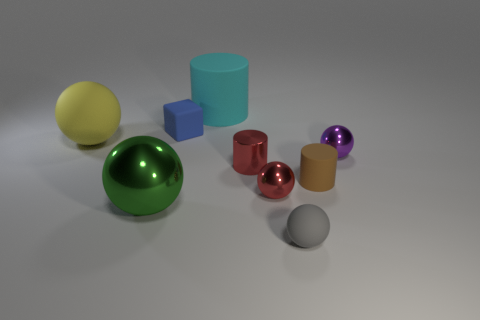What number of other objects are the same material as the red cylinder?
Your answer should be very brief. 3. Is the material of the large object right of the tiny rubber block the same as the tiny blue cube?
Offer a terse response. Yes. What size is the sphere that is behind the metal sphere that is behind the red thing that is to the right of the tiny red cylinder?
Give a very brief answer. Large. How many other things are there of the same color as the small metal cylinder?
Your response must be concise. 1. The purple thing that is the same size as the brown rubber cylinder is what shape?
Provide a succinct answer. Sphere. What is the size of the shiny sphere that is on the left side of the small blue cube?
Keep it short and to the point. Large. Is the color of the big sphere behind the purple metal ball the same as the rubber ball on the right side of the big yellow thing?
Offer a very short reply. No. There is a tiny red object that is behind the red object that is in front of the matte cylinder right of the large cyan cylinder; what is its material?
Keep it short and to the point. Metal. Are there any spheres that have the same size as the green thing?
Give a very brief answer. Yes. There is a brown thing that is the same size as the gray matte thing; what is its material?
Your answer should be very brief. Rubber. 